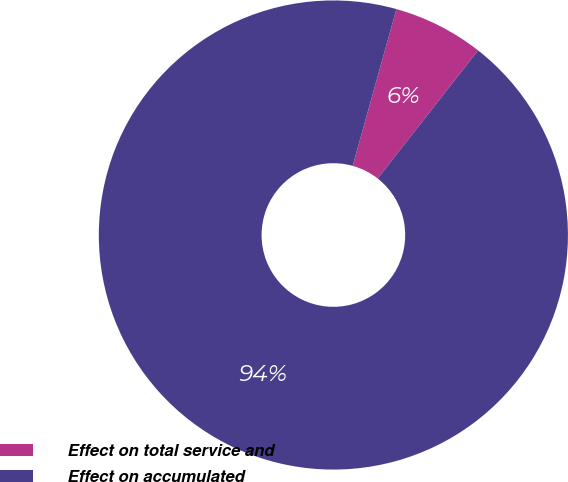<chart> <loc_0><loc_0><loc_500><loc_500><pie_chart><fcel>Effect on total service and<fcel>Effect on accumulated<nl><fcel>6.25%<fcel>93.75%<nl></chart> 